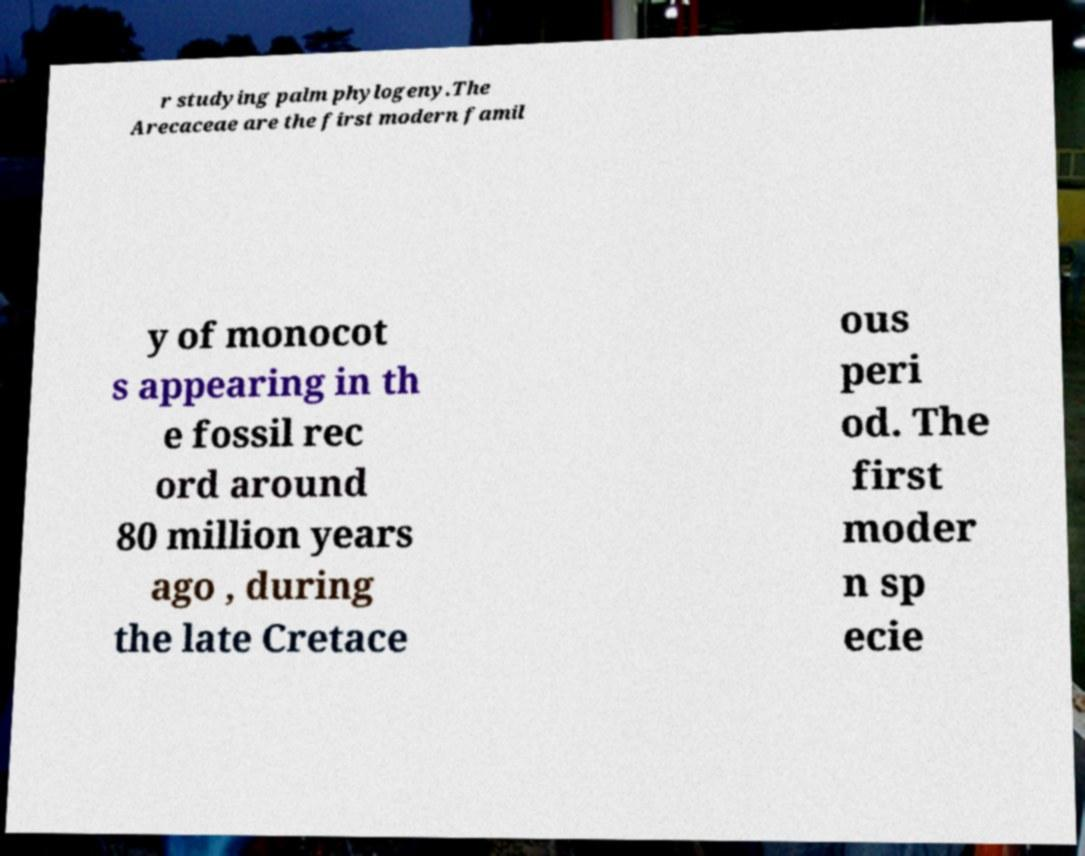For documentation purposes, I need the text within this image transcribed. Could you provide that? r studying palm phylogeny.The Arecaceae are the first modern famil y of monocot s appearing in th e fossil rec ord around 80 million years ago , during the late Cretace ous peri od. The first moder n sp ecie 